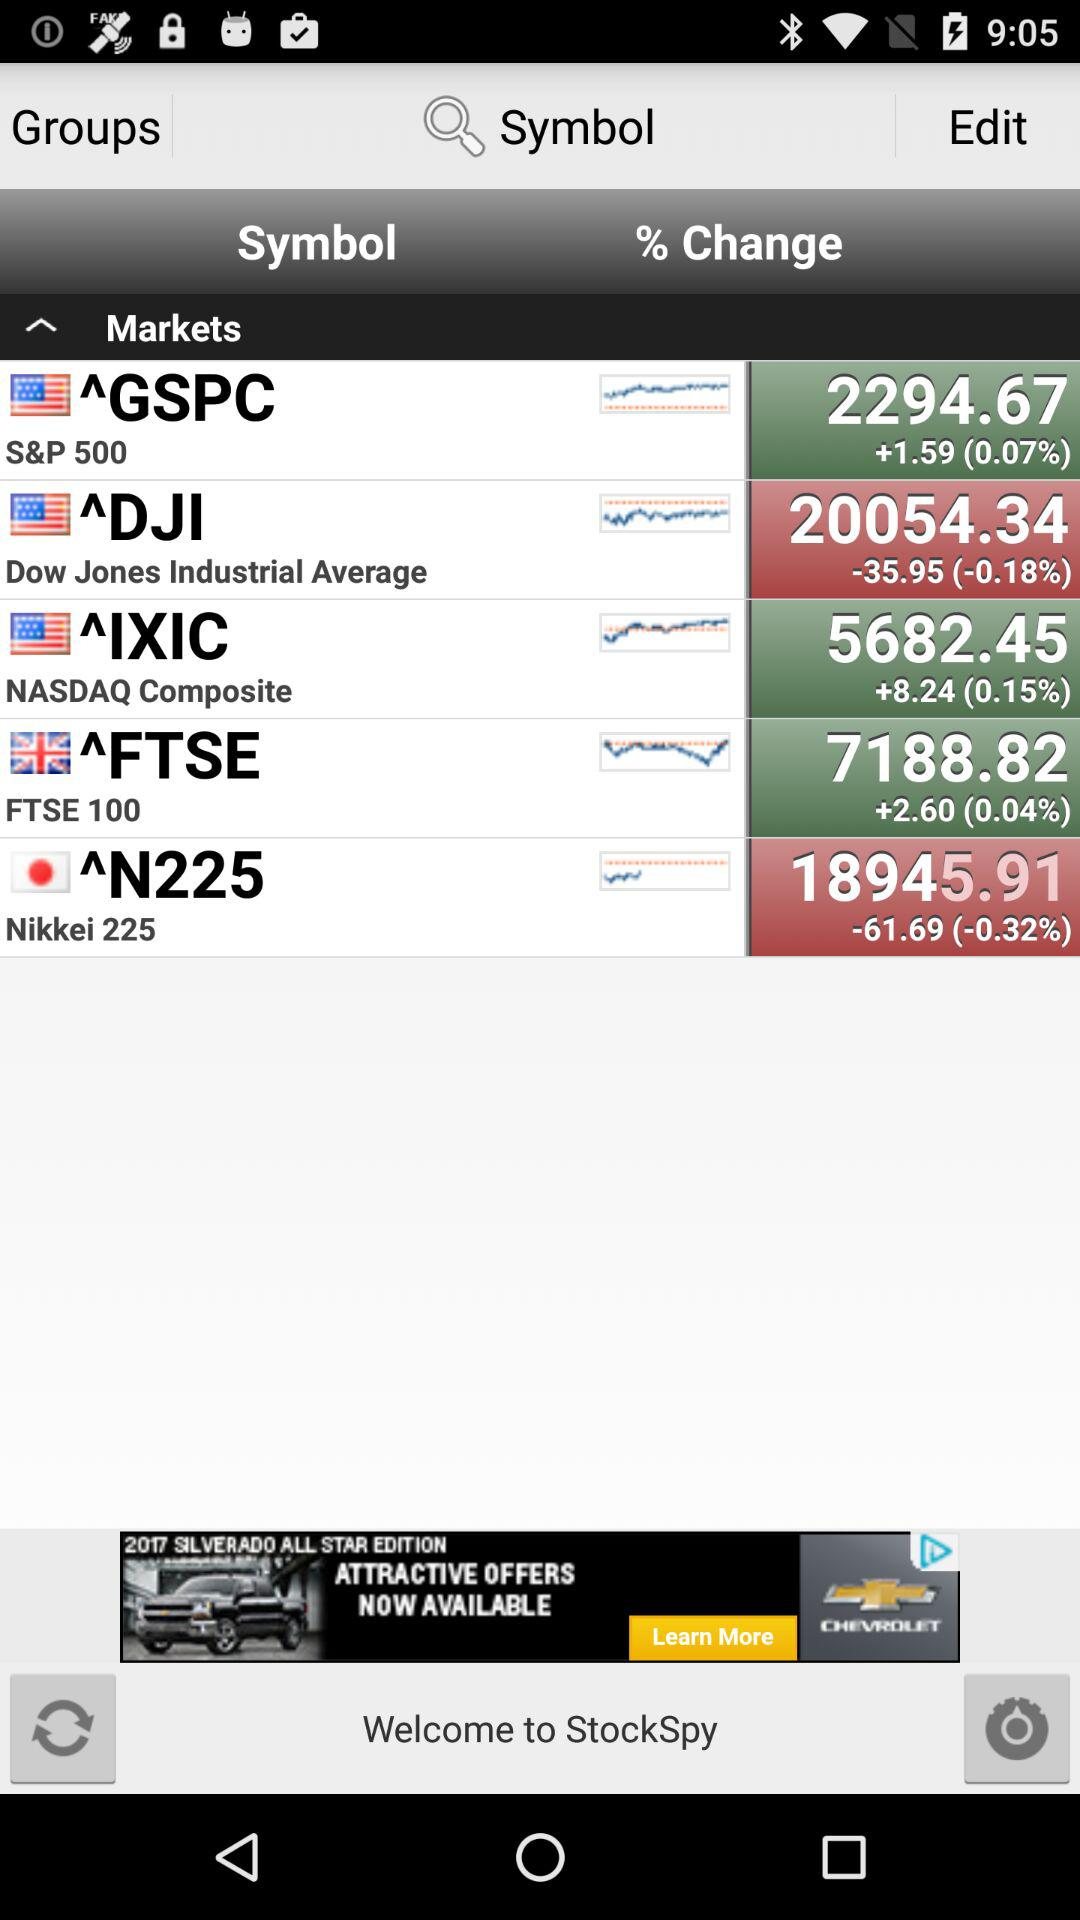What is the percentage change in the FTSE 100? The percentage change in the FTSE 100 is 0.04. 